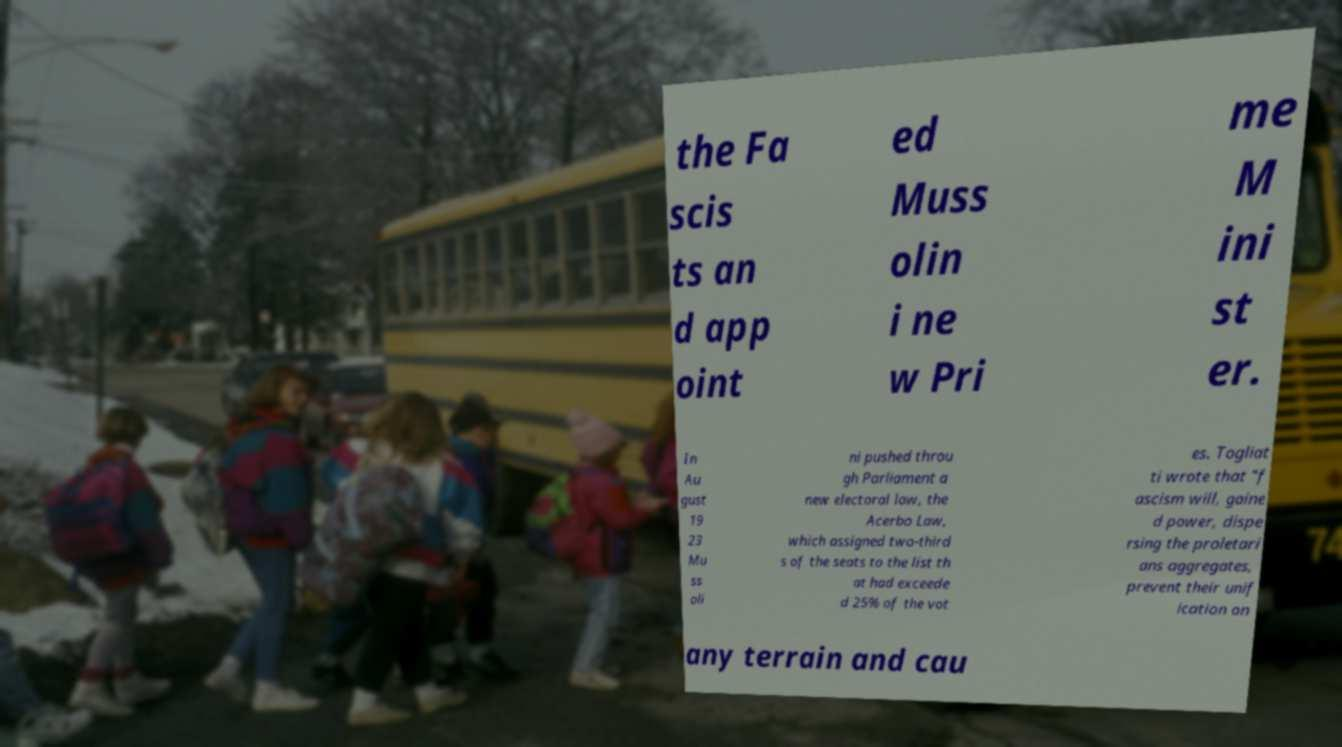Please read and relay the text visible in this image. What does it say? the Fa scis ts an d app oint ed Muss olin i ne w Pri me M ini st er. In Au gust 19 23 Mu ss oli ni pushed throu gh Parliament a new electoral law, the Acerbo Law, which assigned two-third s of the seats to the list th at had exceede d 25% of the vot es. Togliat ti wrote that "f ascism will, gaine d power, dispe rsing the proletari ans aggregates, prevent their unif ication on any terrain and cau 